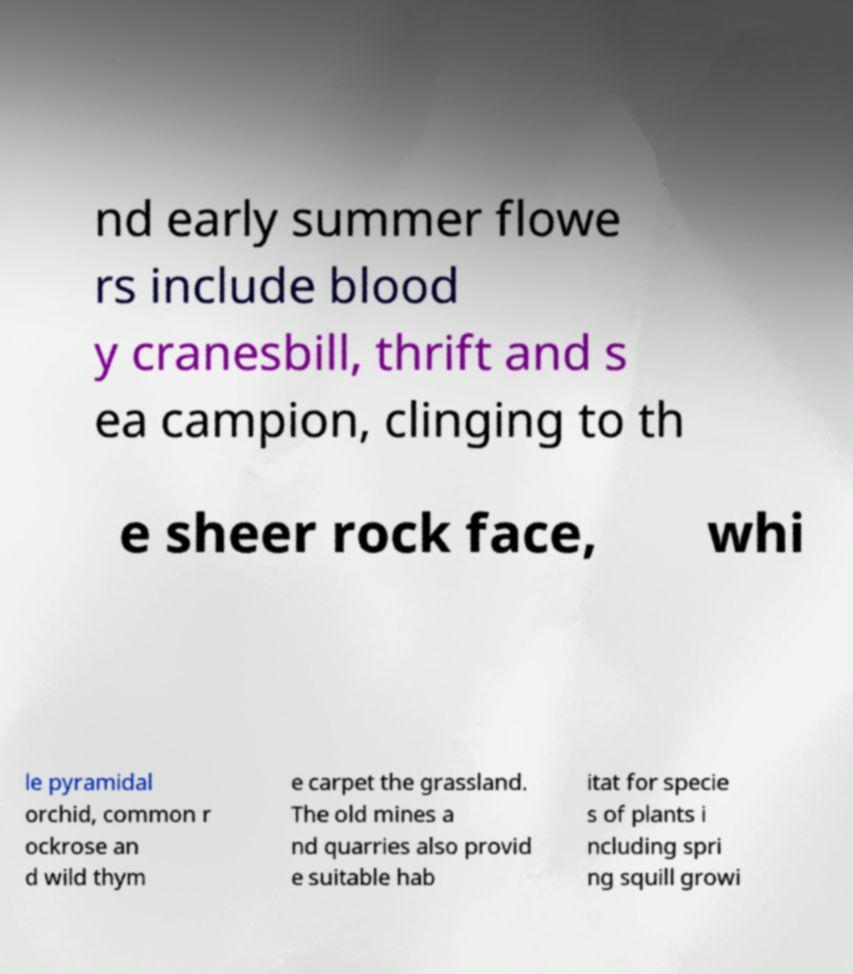Can you accurately transcribe the text from the provided image for me? nd early summer flowe rs include blood y cranesbill, thrift and s ea campion, clinging to th e sheer rock face, whi le pyramidal orchid, common r ockrose an d wild thym e carpet the grassland. The old mines a nd quarries also provid e suitable hab itat for specie s of plants i ncluding spri ng squill growi 